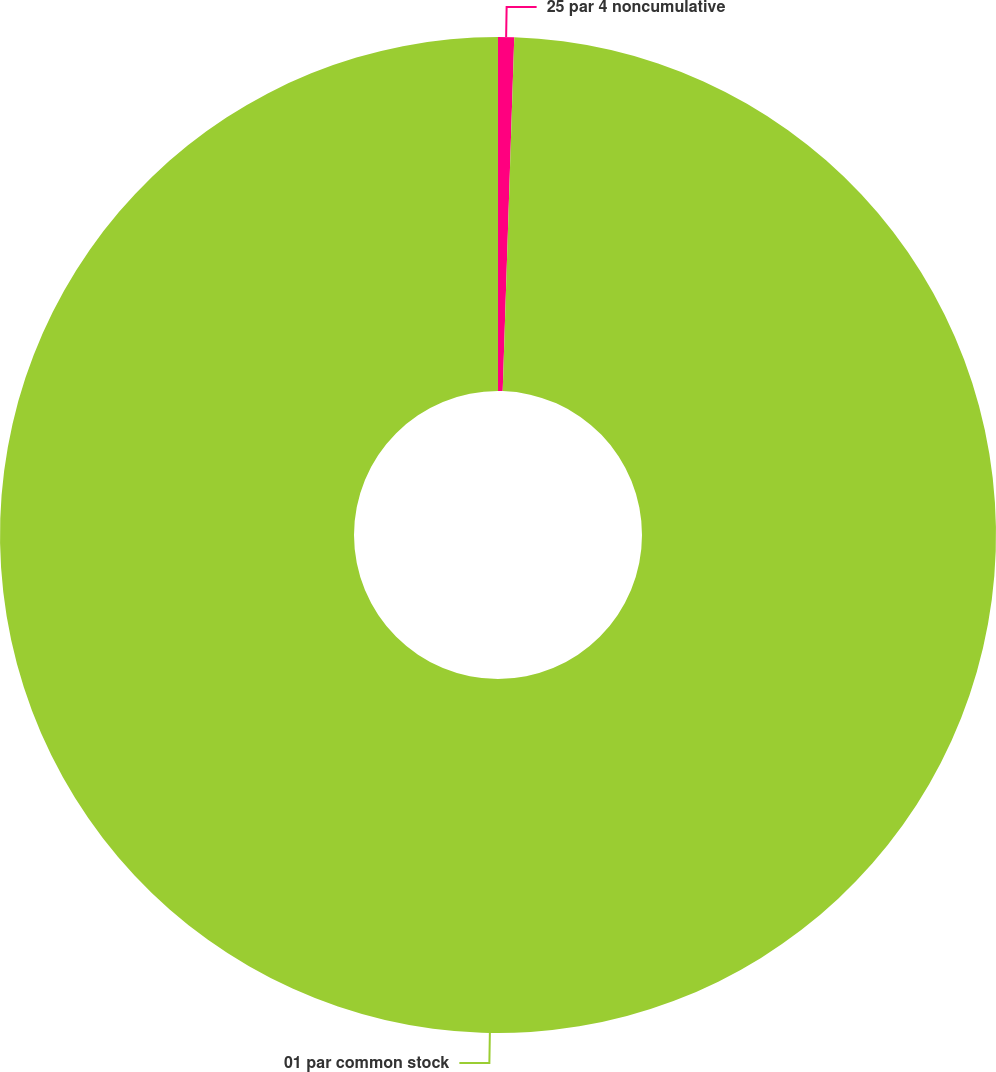Convert chart to OTSL. <chart><loc_0><loc_0><loc_500><loc_500><pie_chart><fcel>25 par 4 noncumulative<fcel>01 par common stock<nl><fcel>0.52%<fcel>99.48%<nl></chart> 